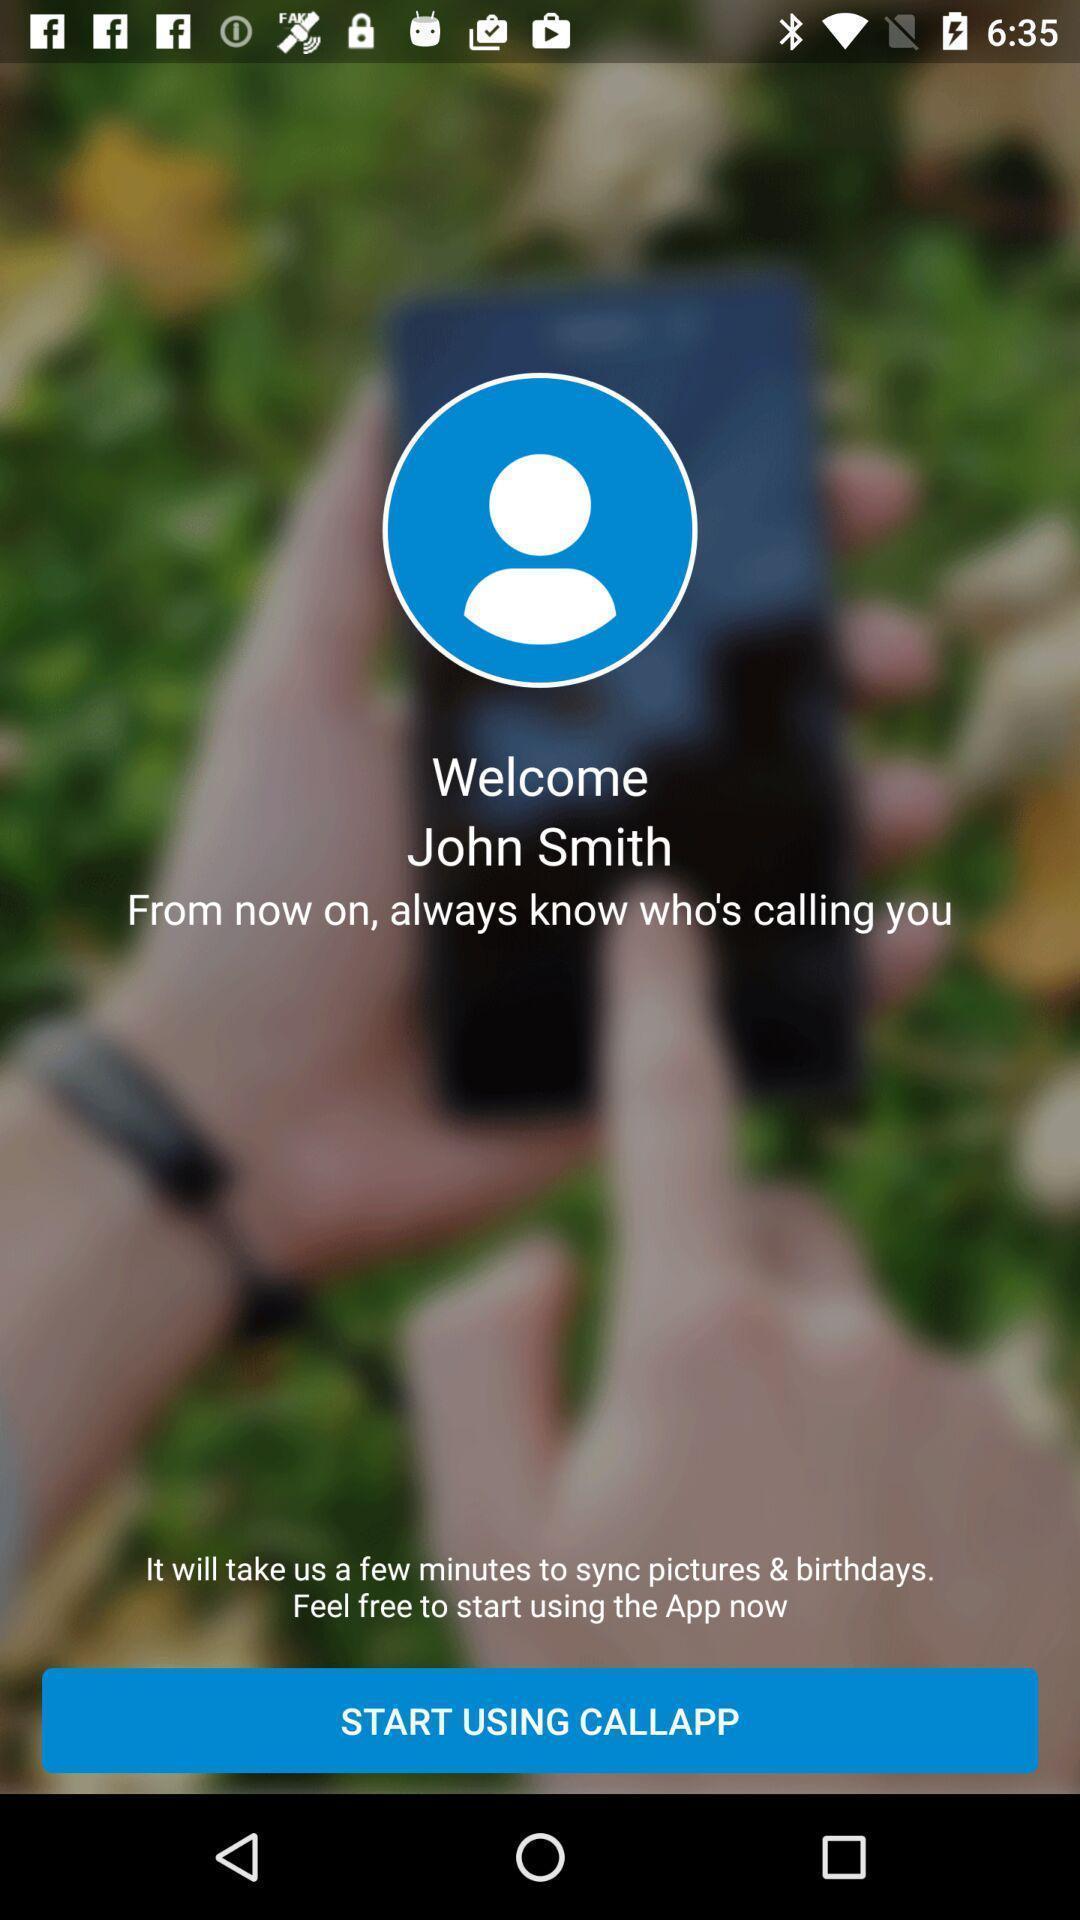Summarize the main components in this picture. Welcome page. 